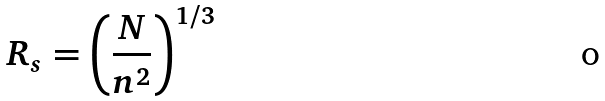<formula> <loc_0><loc_0><loc_500><loc_500>R _ { s } = \left ( \frac { N } { n ^ { 2 } } \right ) ^ { 1 / 3 }</formula> 